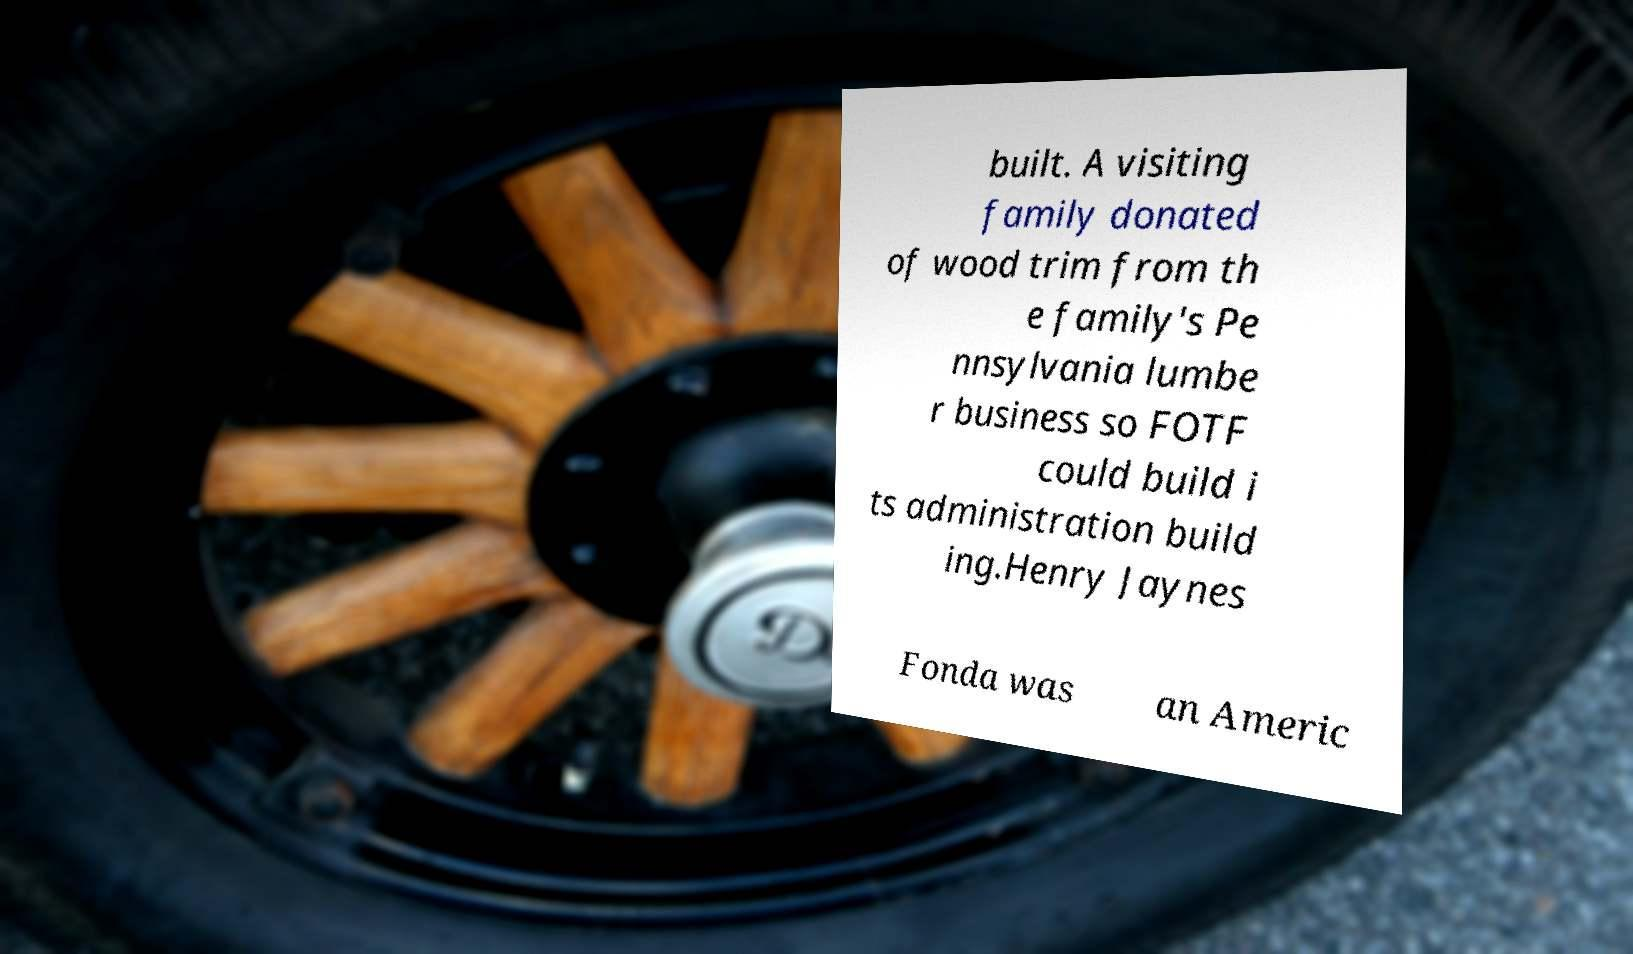Could you assist in decoding the text presented in this image and type it out clearly? built. A visiting family donated of wood trim from th e family's Pe nnsylvania lumbe r business so FOTF could build i ts administration build ing.Henry Jaynes Fonda was an Americ 